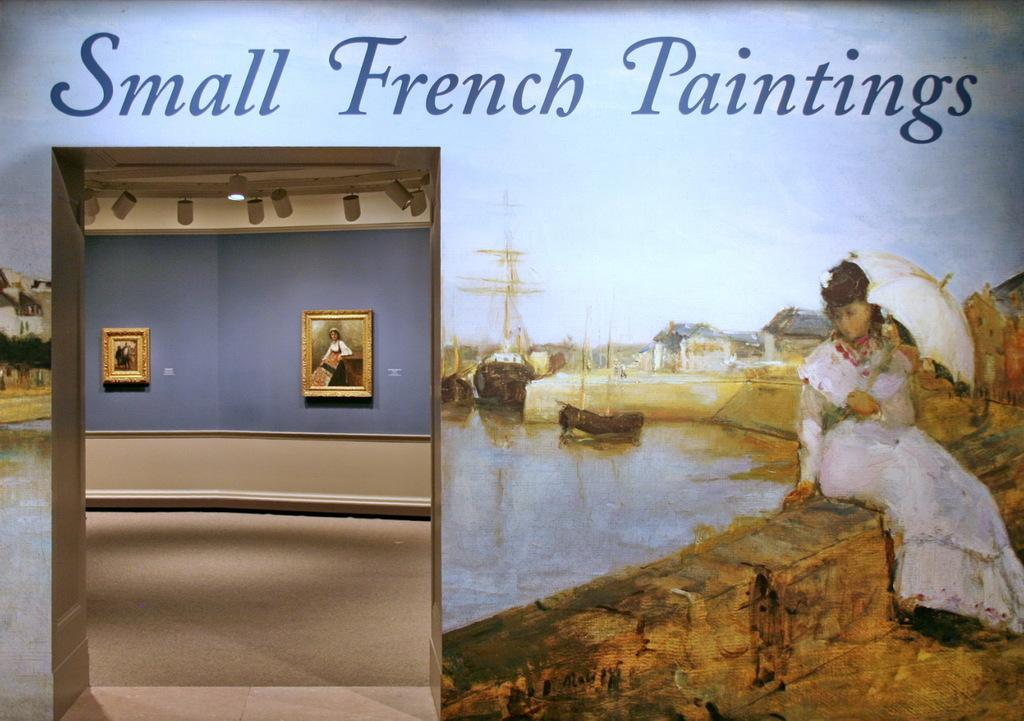What is the main subject of the poster in the image? The poster features a woman sitting. What is the woman holding in the image? The woman is holding an umbrella. What else can be seen in the image besides the poster? There is water visible in the image. What is written on the poster? There is text on the poster. What time of day is it in the image, and is there a sofa visible? The time of day is not mentioned in the image, and there is no sofa visible. Can you tell me how many thumbs the woman has on the poster? The number of thumbs the woman has is not visible in the image. 